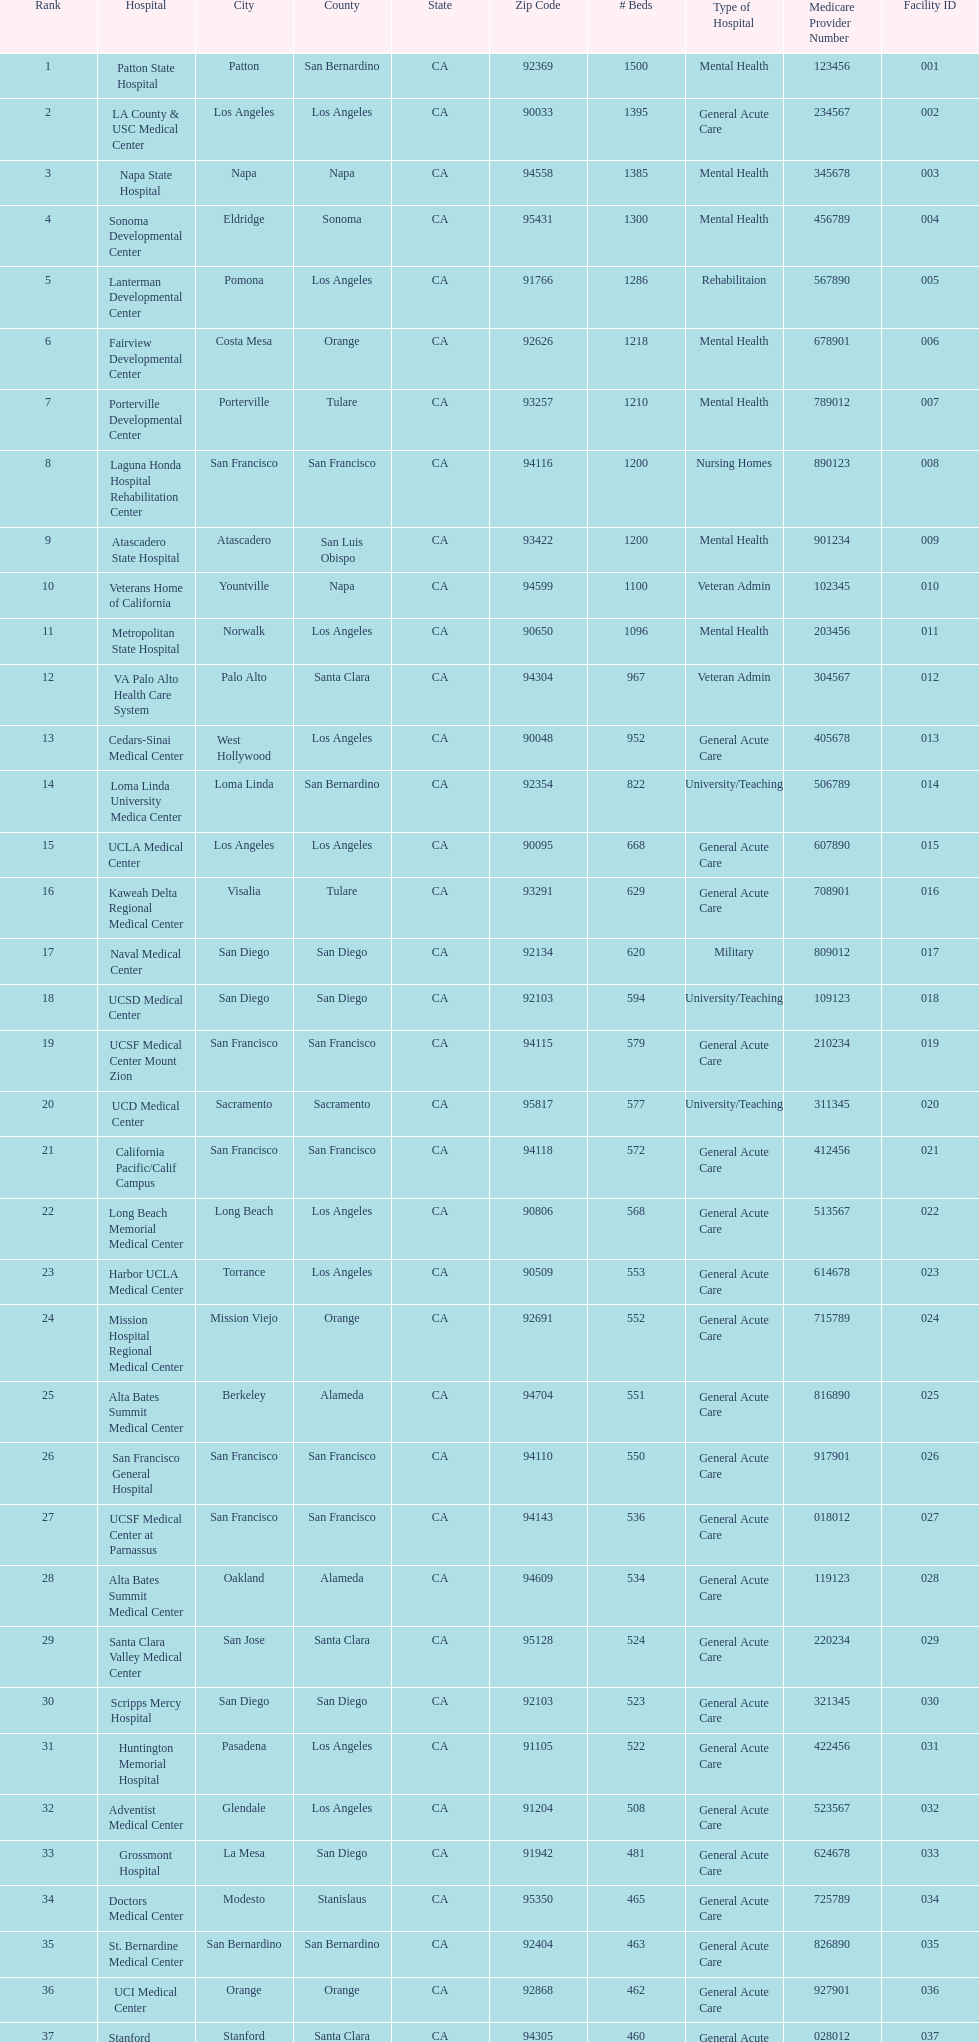What two hospitals holding consecutive rankings of 8 and 9 respectively, both provide 1200 hospital beds? Laguna Honda Hospital Rehabilitation Center, Atascadero State Hospital. 